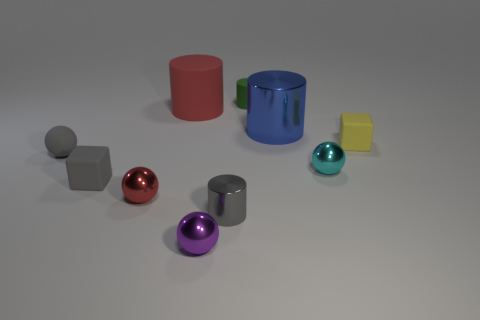Subtract 1 cylinders. How many cylinders are left? 3 Subtract all spheres. How many objects are left? 6 Add 7 purple spheres. How many purple spheres exist? 8 Subtract 0 red cubes. How many objects are left? 10 Subtract all purple metallic spheres. Subtract all cyan rubber cylinders. How many objects are left? 9 Add 5 large rubber cylinders. How many large rubber cylinders are left? 6 